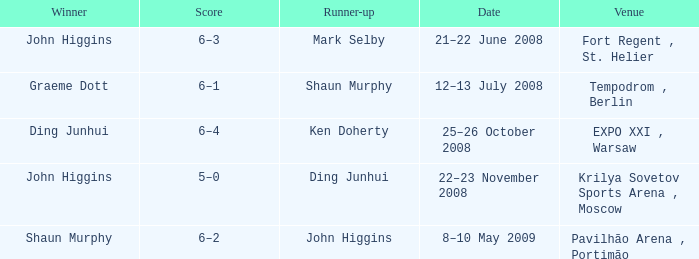Who was the winner in the match that had John Higgins as runner-up? Shaun Murphy. 